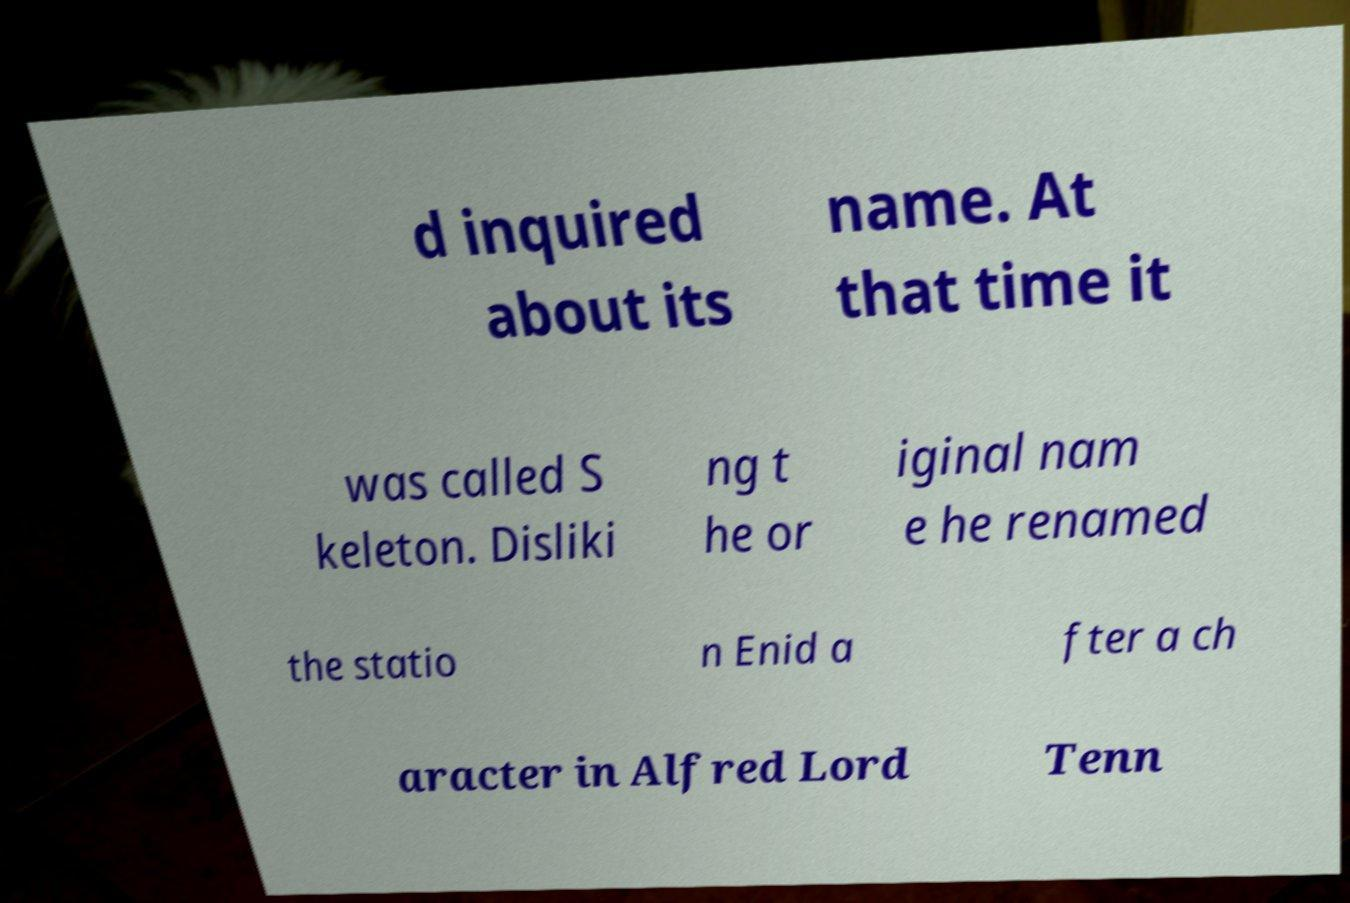I need the written content from this picture converted into text. Can you do that? d inquired about its name. At that time it was called S keleton. Disliki ng t he or iginal nam e he renamed the statio n Enid a fter a ch aracter in Alfred Lord Tenn 